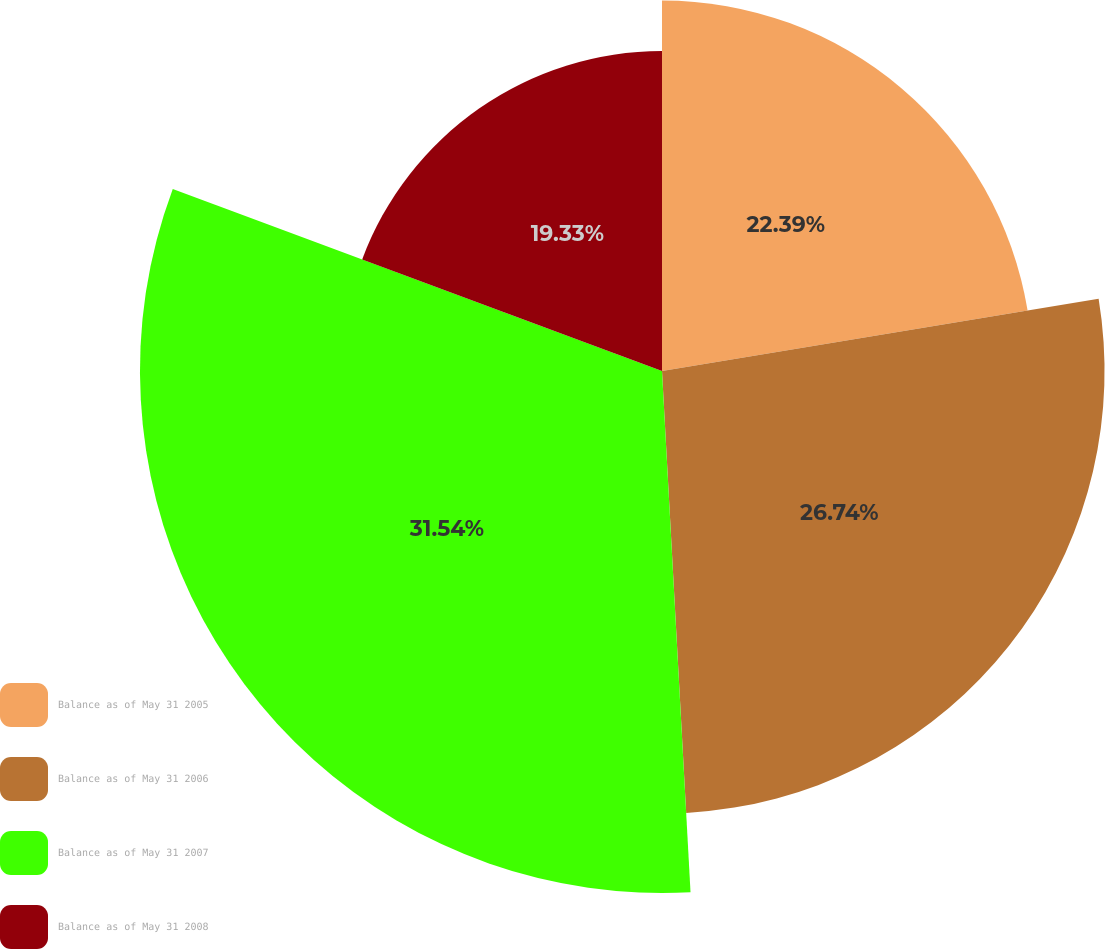Convert chart. <chart><loc_0><loc_0><loc_500><loc_500><pie_chart><fcel>Balance as of May 31 2005<fcel>Balance as of May 31 2006<fcel>Balance as of May 31 2007<fcel>Balance as of May 31 2008<nl><fcel>22.39%<fcel>26.74%<fcel>31.54%<fcel>19.33%<nl></chart> 